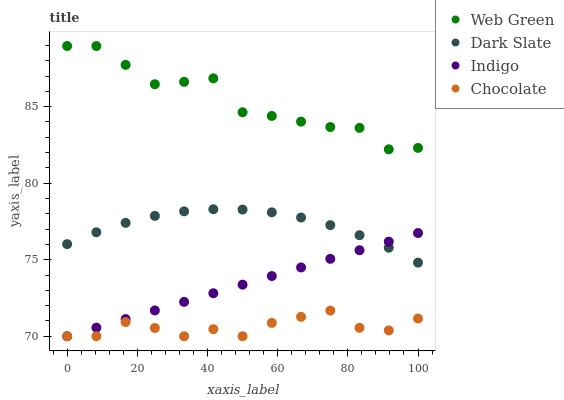Does Chocolate have the minimum area under the curve?
Answer yes or no. Yes. Does Web Green have the maximum area under the curve?
Answer yes or no. Yes. Does Indigo have the minimum area under the curve?
Answer yes or no. No. Does Indigo have the maximum area under the curve?
Answer yes or no. No. Is Indigo the smoothest?
Answer yes or no. Yes. Is Web Green the roughest?
Answer yes or no. Yes. Is Web Green the smoothest?
Answer yes or no. No. Is Indigo the roughest?
Answer yes or no. No. Does Indigo have the lowest value?
Answer yes or no. Yes. Does Web Green have the lowest value?
Answer yes or no. No. Does Web Green have the highest value?
Answer yes or no. Yes. Does Indigo have the highest value?
Answer yes or no. No. Is Chocolate less than Web Green?
Answer yes or no. Yes. Is Web Green greater than Chocolate?
Answer yes or no. Yes. Does Indigo intersect Dark Slate?
Answer yes or no. Yes. Is Indigo less than Dark Slate?
Answer yes or no. No. Is Indigo greater than Dark Slate?
Answer yes or no. No. Does Chocolate intersect Web Green?
Answer yes or no. No. 